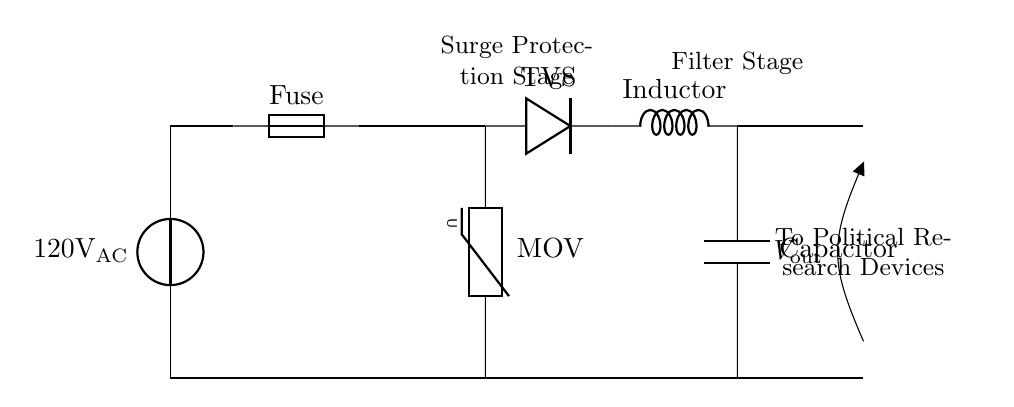What is the input voltage of the circuit? The circuit shows a voltage source labeled as 120V AC, indicating the potential difference provided to the circuit.
Answer: 120V AC What components are used for surge protection? The circuit includes a varistor (MOV) and a transient voltage suppressor (TVS), both of which are designed to protect against voltage spikes.
Answer: Varistor and TVS What is the purpose of the inductor in the circuit? The inductor is part of the filter stage, which smooths out the current and reduces electromagnetic interference. Its primary function is to block high-frequency noise while allowing low-frequency current to pass through.
Answer: Filtering How do you connect the output of the surge protection to the devices? The output voltage is labeled as V_out, indicating that current flows from the output terminal after the filtering components directly to the political research devices. This shows a direct connection without any additional components in between.
Answer: Direct connection What role does the capacitor play in this circuit? The capacitor is also part of the filter stage and acts to absorb and store electrical energy, which helps to smooth out fluctuations in current. This results in a more stable supply voltage for the devices.
Answer: Smoothing voltage How does the fuse contribute to the safety of the circuit? The fuse is designed to protect the circuit by interrupting the flow of current if it exceeds a certain level, preventing potential damage to components due to overcurrent conditions.
Answer: Protective device 